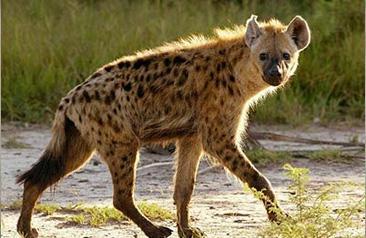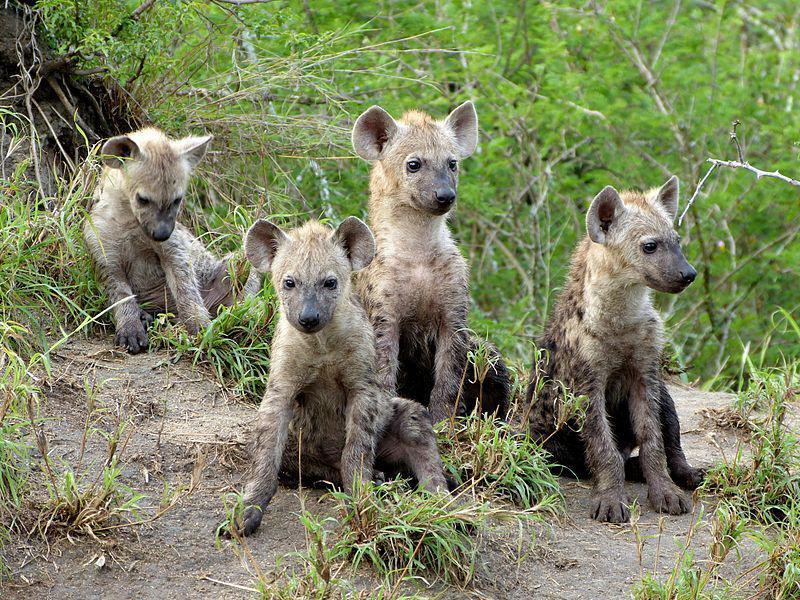The first image is the image on the left, the second image is the image on the right. Evaluate the accuracy of this statement regarding the images: "The image on the left has one hyena that is facing towards the right.". Is it true? Answer yes or no. Yes. The first image is the image on the left, the second image is the image on the right. Examine the images to the left and right. Is the description "There are at most 4 hyenas." accurate? Answer yes or no. No. 